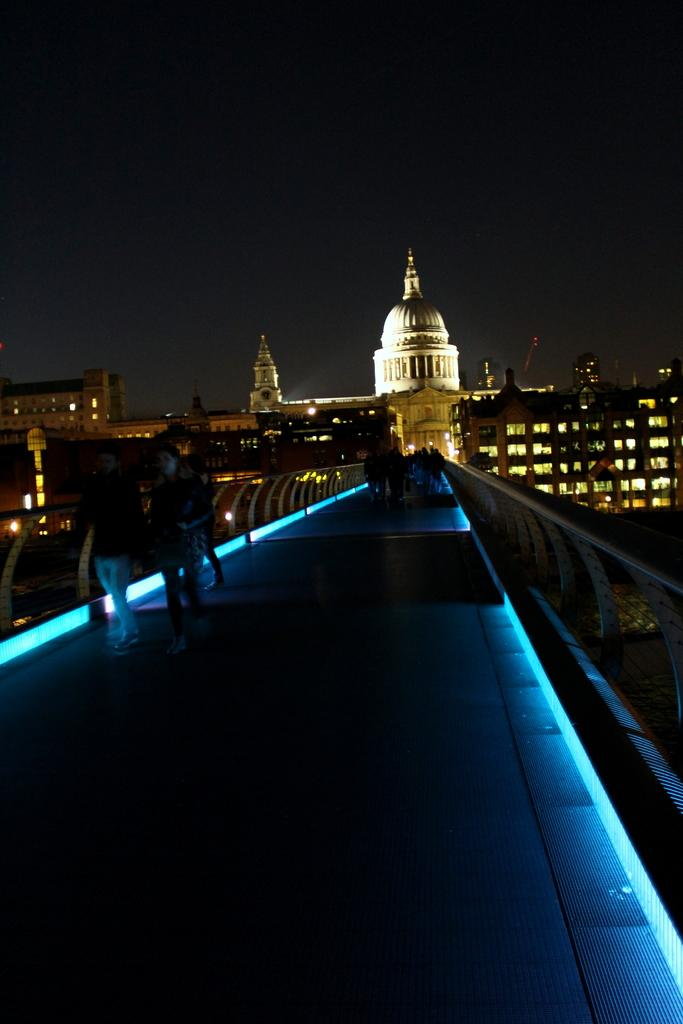What can be seen on the bridge in the image? There are people on the bridge in the image. What is visible in the background of the image? There are buildings with windows in the background. What type of seed is being used to play volleyball in the image? There is no seed or volleyball present in the image; it features people on a bridge and buildings in the background. 